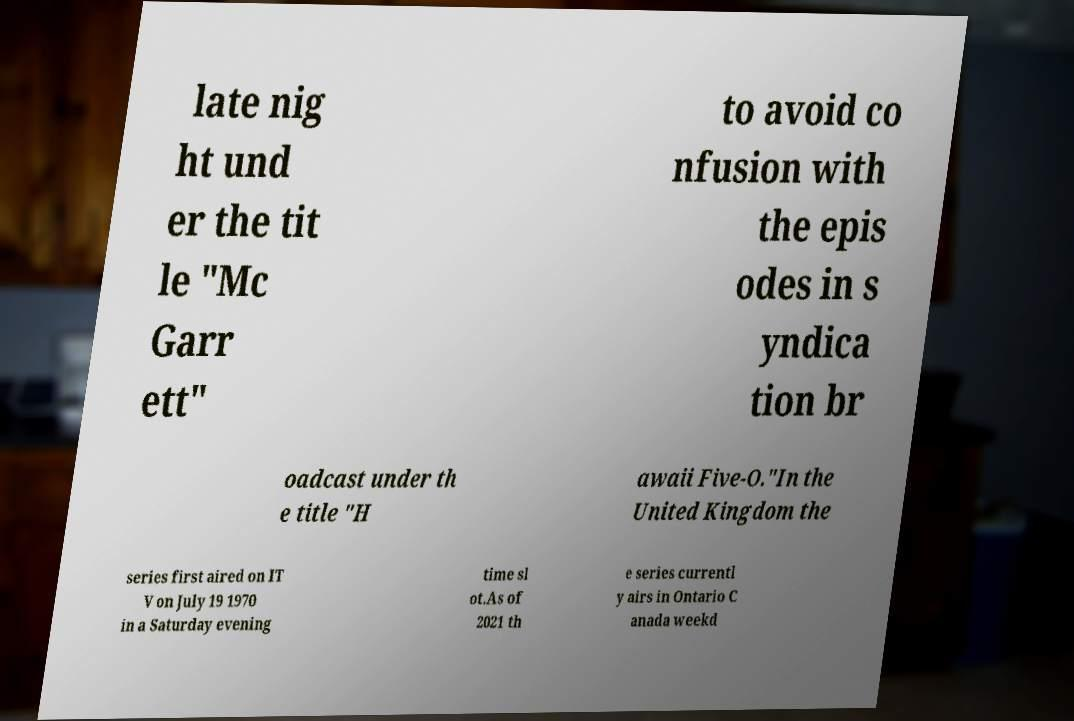I need the written content from this picture converted into text. Can you do that? late nig ht und er the tit le "Mc Garr ett" to avoid co nfusion with the epis odes in s yndica tion br oadcast under th e title "H awaii Five-O."In the United Kingdom the series first aired on IT V on July 19 1970 in a Saturday evening time sl ot.As of 2021 th e series currentl y airs in Ontario C anada weekd 